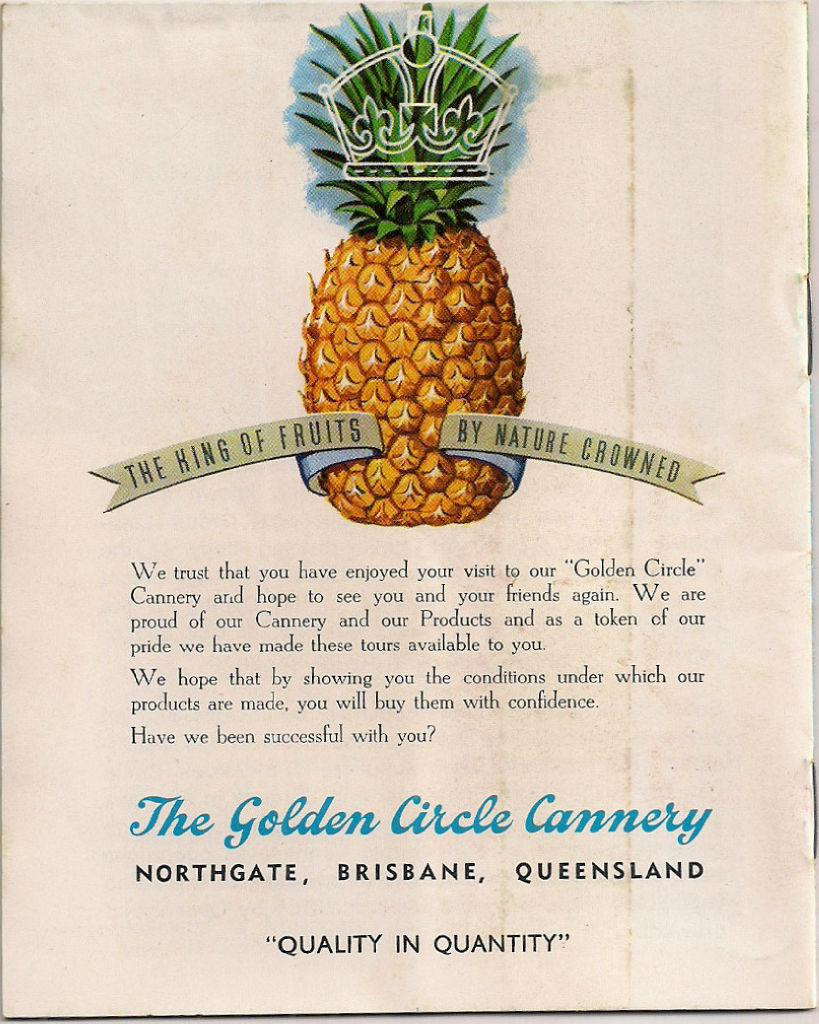What is present in the image that features an image? There is a poster in the image that contains an image. What type of image is on the poster? The image on the poster is of a pineapple. What else can be found on the poster besides the image? There is text written on the poster. What color is the stitch on the apple in the image? There is no apple or stitch present in the image; it features a poster with a pineapple image and text. 